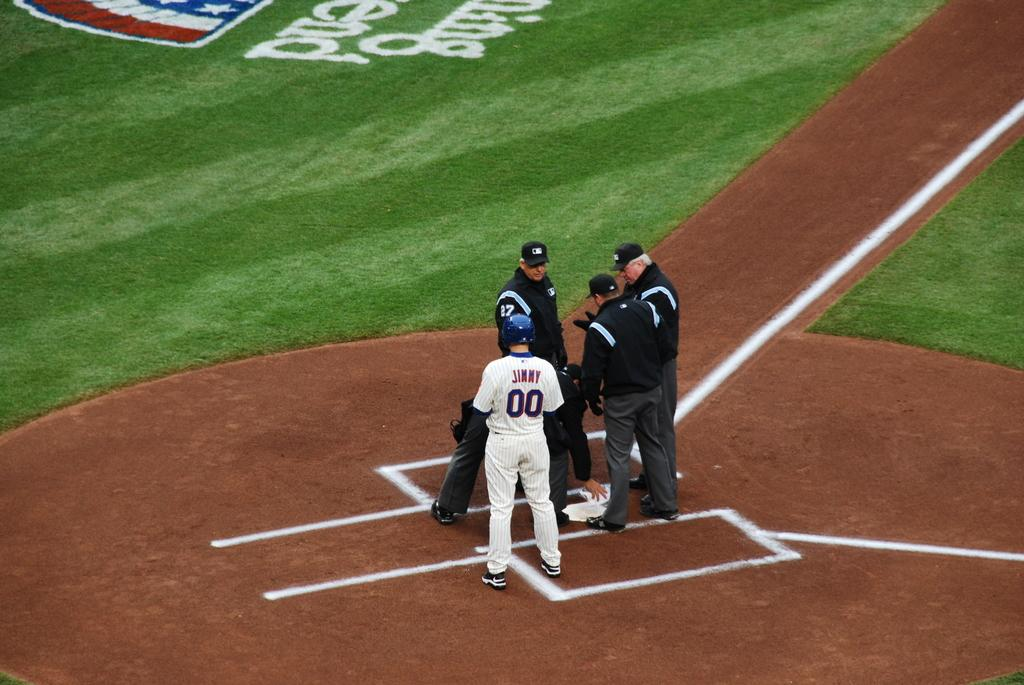<image>
Present a compact description of the photo's key features. A baseball player is standing with referees at home plate and has the name Jimmy on his jersey. 